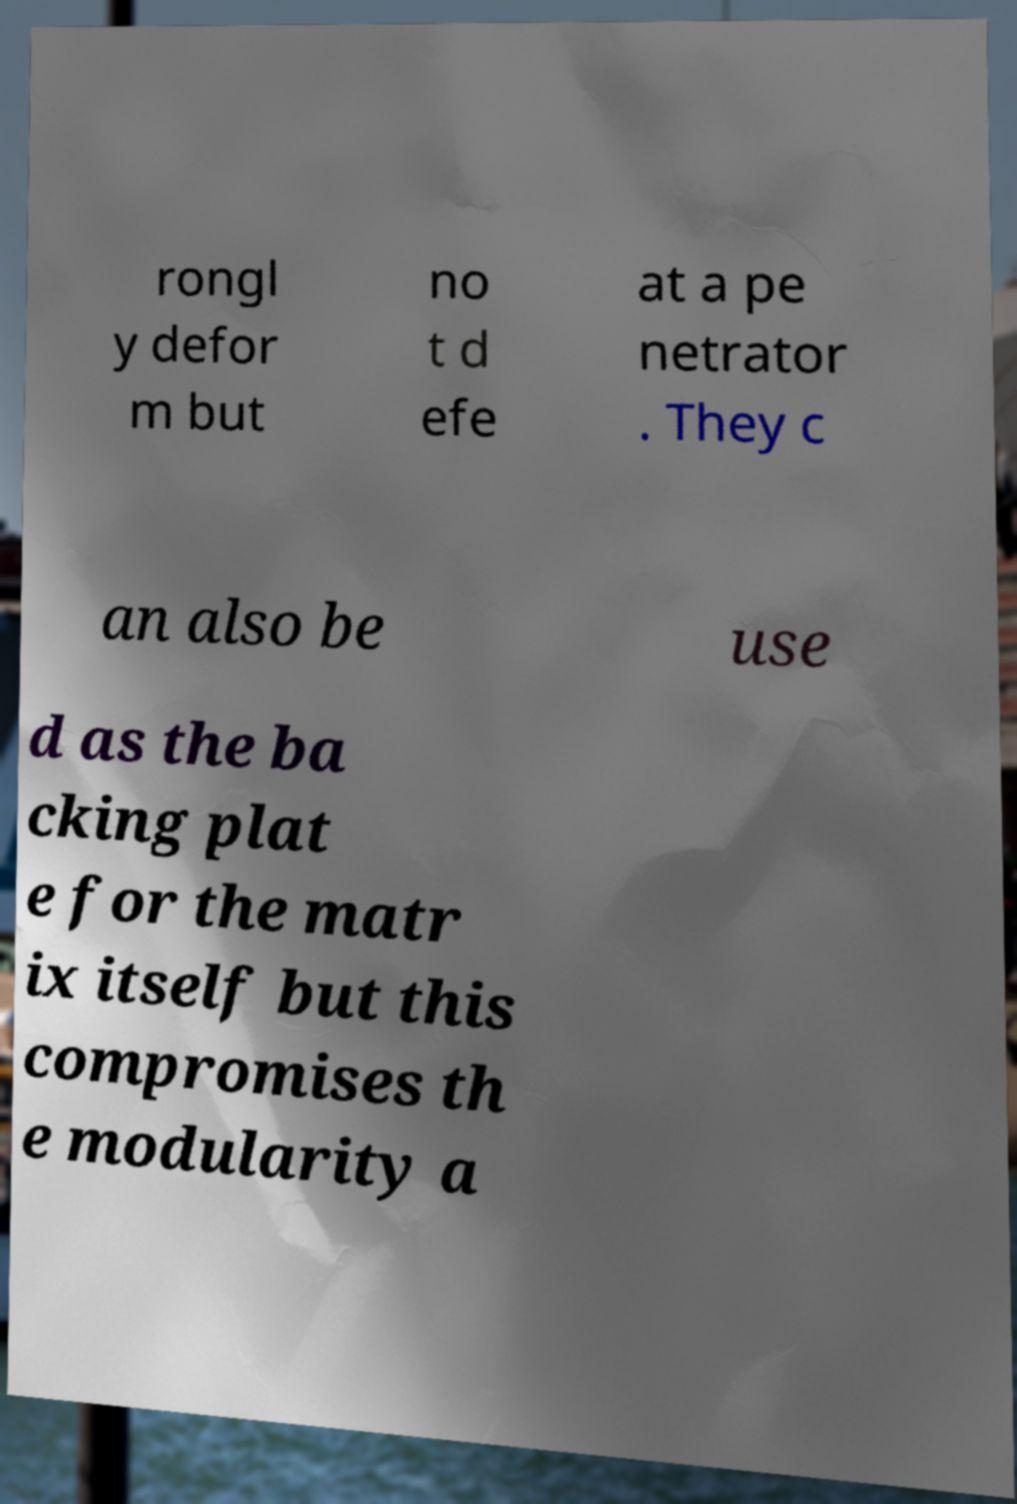There's text embedded in this image that I need extracted. Can you transcribe it verbatim? rongl y defor m but no t d efe at a pe netrator . They c an also be use d as the ba cking plat e for the matr ix itself but this compromises th e modularity a 